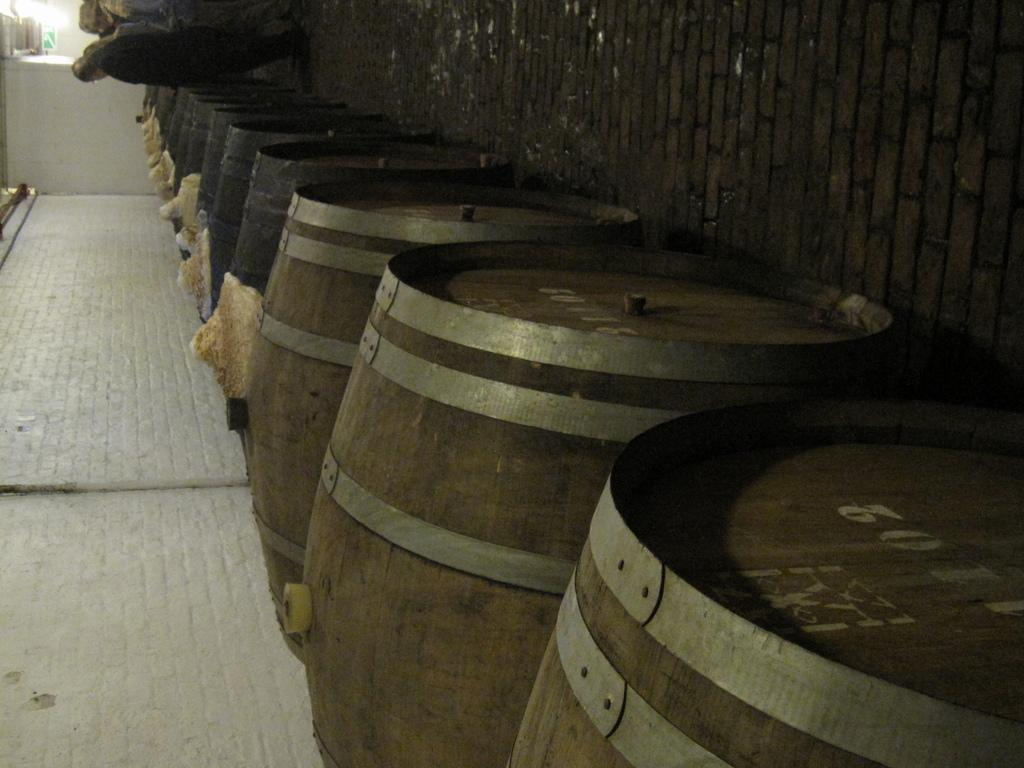<image>
Write a terse but informative summary of the picture. People looking at barrels with the first barrel having a white number 2 on it. 